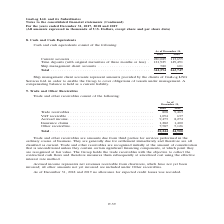From Gaslog's financial document, What are the components of trade and other receivables? The document contains multiple relevant values: Trade receivables, VAT receivable, Accrued income, Insurance claims, Other receivables. From the document: "ceivable . 1,094 637 Accrued income . 9,473 8,274 Insurance claims . 1,282 1,400 Other receivables . 7,587 5,126 Trade receivables . 808 9,463 VAT rec..." Also, Why does the Group hold the trade receivables? The Group holds the trade receivables with the objective to collect the contractual cash flows. The document states: "at which point they are recognized at fair value. The Group holds the trade receivables with the objective to collect the contractual cash flows and t..." Also, What does accrued income represent? Accrued income represents net revenues receivable from charterers, which have not yet been invoiced. The document states: "Accrued income represents net revenues receivable from charterers, which have not yet been invoiced; all other amounts not yet invoiced are included u..." Additionally, In which year was the insurance claims higher? According to the financial document, 2019. The relevant text states: ") For the years ended December 31, 2017, 2018 and 2019 (All amounts expressed in thousands of U.S. Dollars, except share and per share data)..." Also, can you calculate: What was the change in trade receivables from 2018 to 2019? Based on the calculation: 9,463 - 808 , the result is 8655 (in thousands). This is based on the information: "Trade receivables . 808 9,463 VAT receivable . 1,094 637 Accrued income . 9,473 8,274 Insurance claims . 1,282 1,400 Other receiv Trade receivables . 808 9,463 VAT receivable . 1,094 637 Accrued incom..." The key data points involved are: 808, 9,463. Also, can you calculate: What was the percentage change in total receivables from 2018 to 2019? To answer this question, I need to perform calculations using the financial data. The calculation is: (24,900 - 20,244)/20,244 , which equals 23 (percentage). This is based on the information: "Total . 20,244 24,900 Total . 20,244 24,900..." The key data points involved are: 20,244, 24,900. 